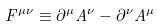<formula> <loc_0><loc_0><loc_500><loc_500>F ^ { \mu \nu } \equiv \partial ^ { \mu } A ^ { \nu } - \partial ^ { \nu } A ^ { \mu }</formula> 